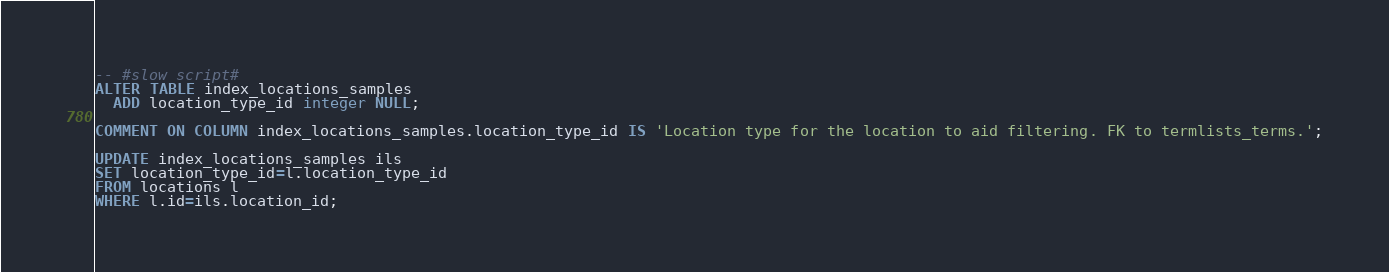Convert code to text. <code><loc_0><loc_0><loc_500><loc_500><_SQL_>-- #slow script#
ALTER TABLE index_locations_samples
  ADD location_type_id integer NULL;

COMMENT ON COLUMN index_locations_samples.location_type_id IS 'Location type for the location to aid filtering. FK to termlists_terms.';

UPDATE index_locations_samples ils
SET location_type_id=l.location_type_id
FROM locations l
WHERE l.id=ils.location_id;
</code> 